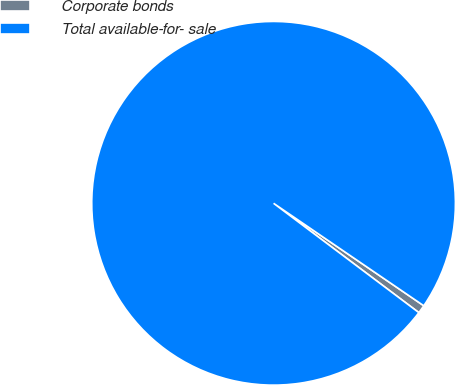Convert chart. <chart><loc_0><loc_0><loc_500><loc_500><pie_chart><fcel>Corporate bonds<fcel>Total available-for- sale<nl><fcel>0.74%<fcel>99.26%<nl></chart> 